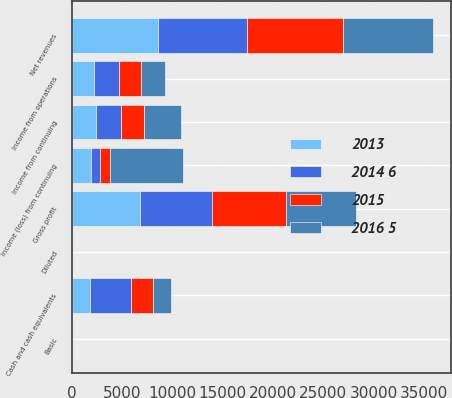<chart> <loc_0><loc_0><loc_500><loc_500><stacked_bar_chart><ecel><fcel>Net revenues<fcel>Gross profit<fcel>Income from operations<fcel>Income from continuing<fcel>Income (loss) from continuing<fcel>Basic<fcel>Diluted<fcel>Cash and cash equivalents<nl><fcel>2015<fcel>9567<fcel>7345<fcel>2265<fcel>2276<fcel>1012<fcel>0.95<fcel>0.95<fcel>2120<nl><fcel>2016 5<fcel>8979<fcel>6972<fcel>2325<fcel>3651<fcel>7285<fcel>6.43<fcel>6.37<fcel>1816<nl><fcel>2013<fcel>8592<fcel>6821<fcel>2197<fcel>2406<fcel>1947<fcel>1.61<fcel>1.6<fcel>1832<nl><fcel>2014 6<fcel>8790<fcel>7127<fcel>2476<fcel>2515<fcel>865<fcel>0.69<fcel>0.69<fcel>4105<nl></chart> 